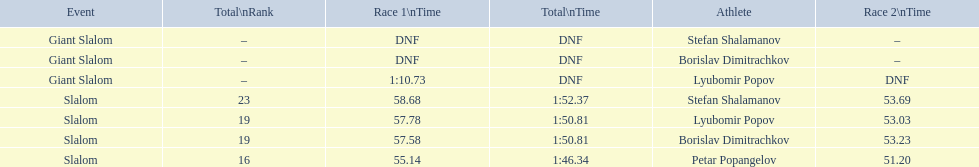What are all the competitions lyubomir popov competed in? Lyubomir Popov, Lyubomir Popov. Of those, which were giant slalom races? Giant Slalom. What was his time in race 1? 1:10.73. 